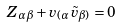Convert formula to latex. <formula><loc_0><loc_0><loc_500><loc_500>Z _ { \alpha \beta } + v _ { ( \alpha } \tilde { v } _ { \beta ) } = 0</formula> 